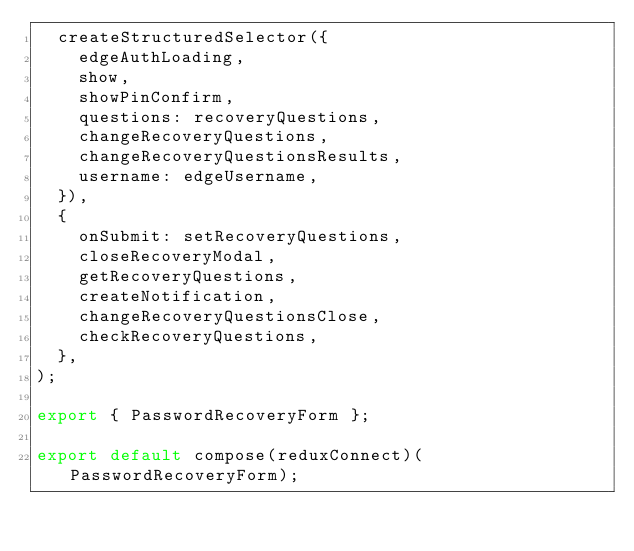<code> <loc_0><loc_0><loc_500><loc_500><_JavaScript_>  createStructuredSelector({
    edgeAuthLoading,
    show,
    showPinConfirm,
    questions: recoveryQuestions,
    changeRecoveryQuestions,
    changeRecoveryQuestionsResults,
    username: edgeUsername,
  }),
  {
    onSubmit: setRecoveryQuestions,
    closeRecoveryModal,
    getRecoveryQuestions,
    createNotification,
    changeRecoveryQuestionsClose,
    checkRecoveryQuestions,
  },
);

export { PasswordRecoveryForm };

export default compose(reduxConnect)(PasswordRecoveryForm);
</code> 